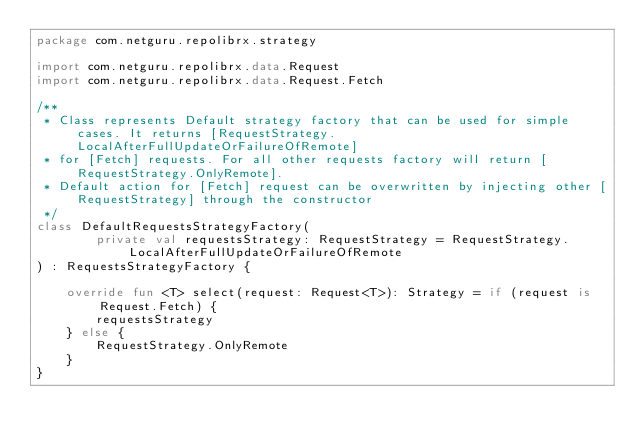Convert code to text. <code><loc_0><loc_0><loc_500><loc_500><_Kotlin_>package com.netguru.repolibrx.strategy

import com.netguru.repolibrx.data.Request
import com.netguru.repolibrx.data.Request.Fetch

/**
 * Class represents Default strategy factory that can be used for simple cases. It returns [RequestStrategy.LocalAfterFullUpdateOrFailureOfRemote]
 * for [Fetch] requests. For all other requests factory will return [RequestStrategy.OnlyRemote].
 * Default action for [Fetch] request can be overwritten by injecting other [RequestStrategy] through the constructor
 */
class DefaultRequestsStrategyFactory(
        private val requestsStrategy: RequestStrategy = RequestStrategy.LocalAfterFullUpdateOrFailureOfRemote
) : RequestsStrategyFactory {

    override fun <T> select(request: Request<T>): Strategy = if (request is Request.Fetch) {
        requestsStrategy
    } else {
        RequestStrategy.OnlyRemote
    }
}</code> 